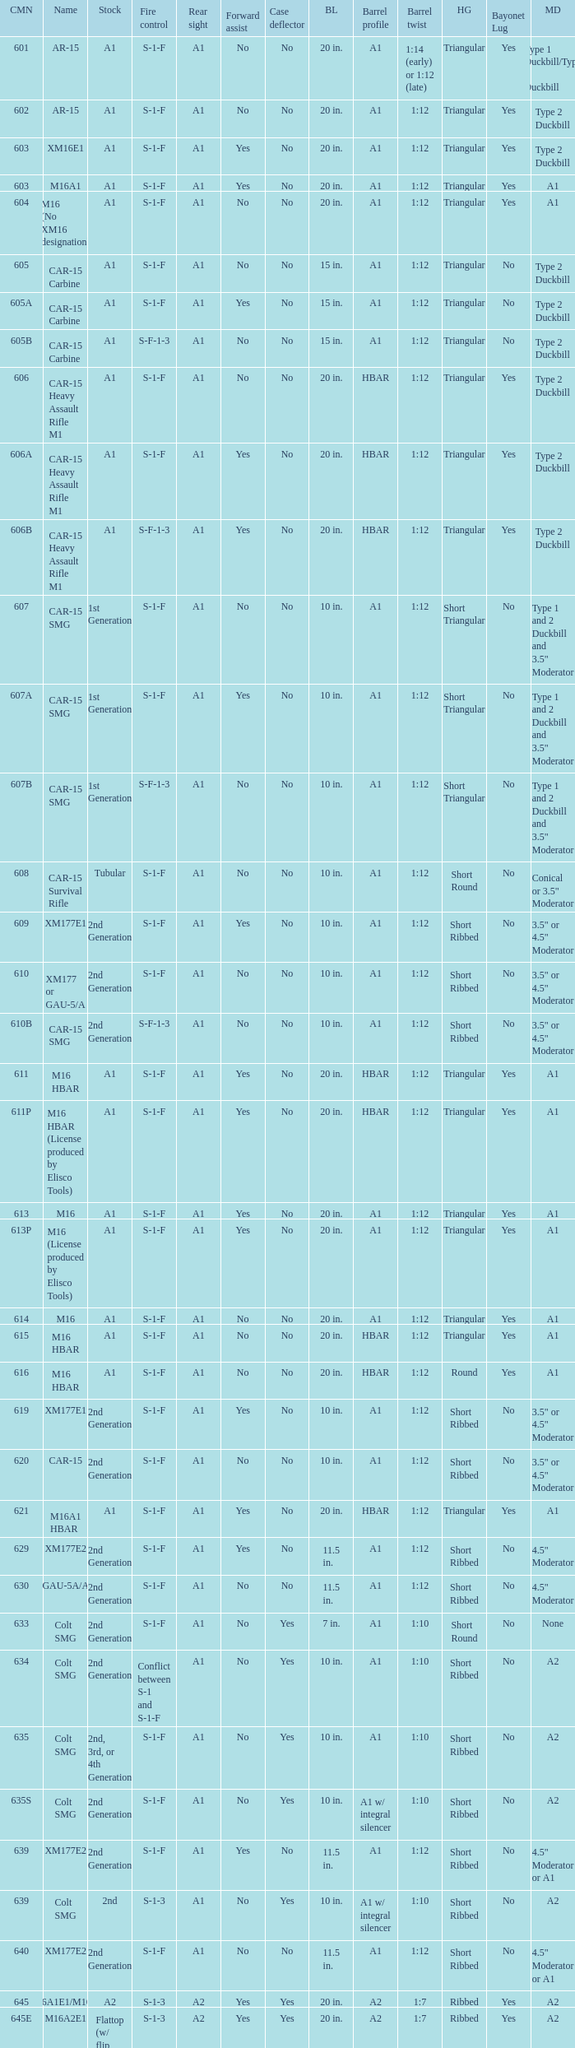What is the rear sight in the Cole model no. 735? A1 or A2. 